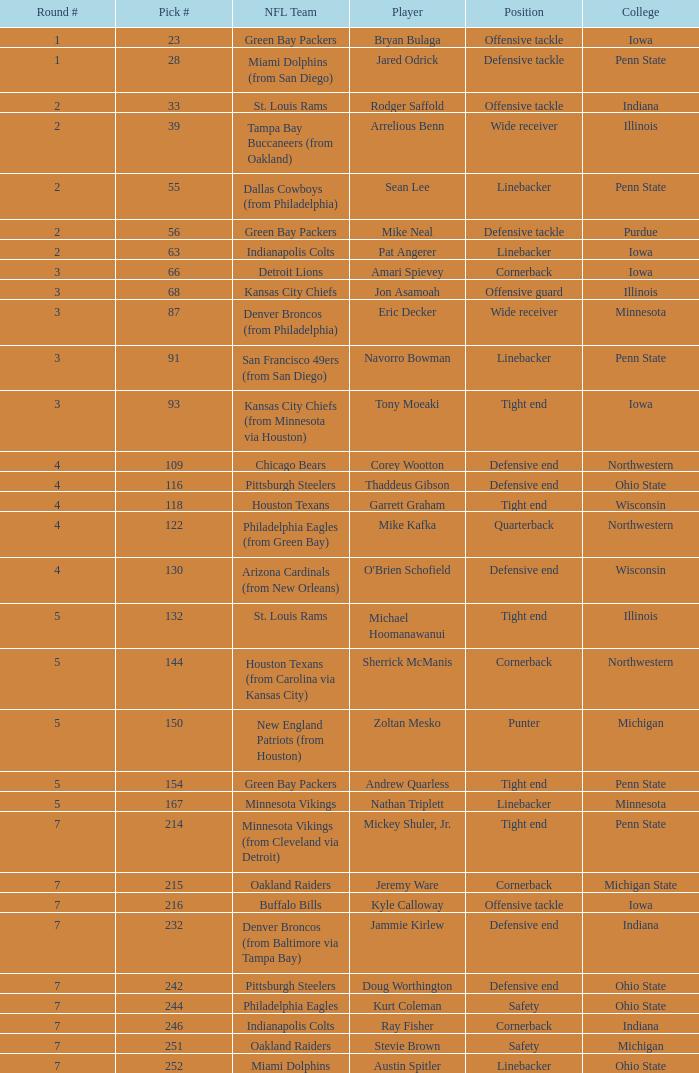What was Sherrick McManis's earliest round? 5.0. 